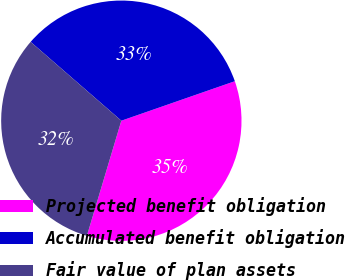<chart> <loc_0><loc_0><loc_500><loc_500><pie_chart><fcel>Projected benefit obligation<fcel>Accumulated benefit obligation<fcel>Fair value of plan assets<nl><fcel>34.96%<fcel>33.28%<fcel>31.76%<nl></chart> 